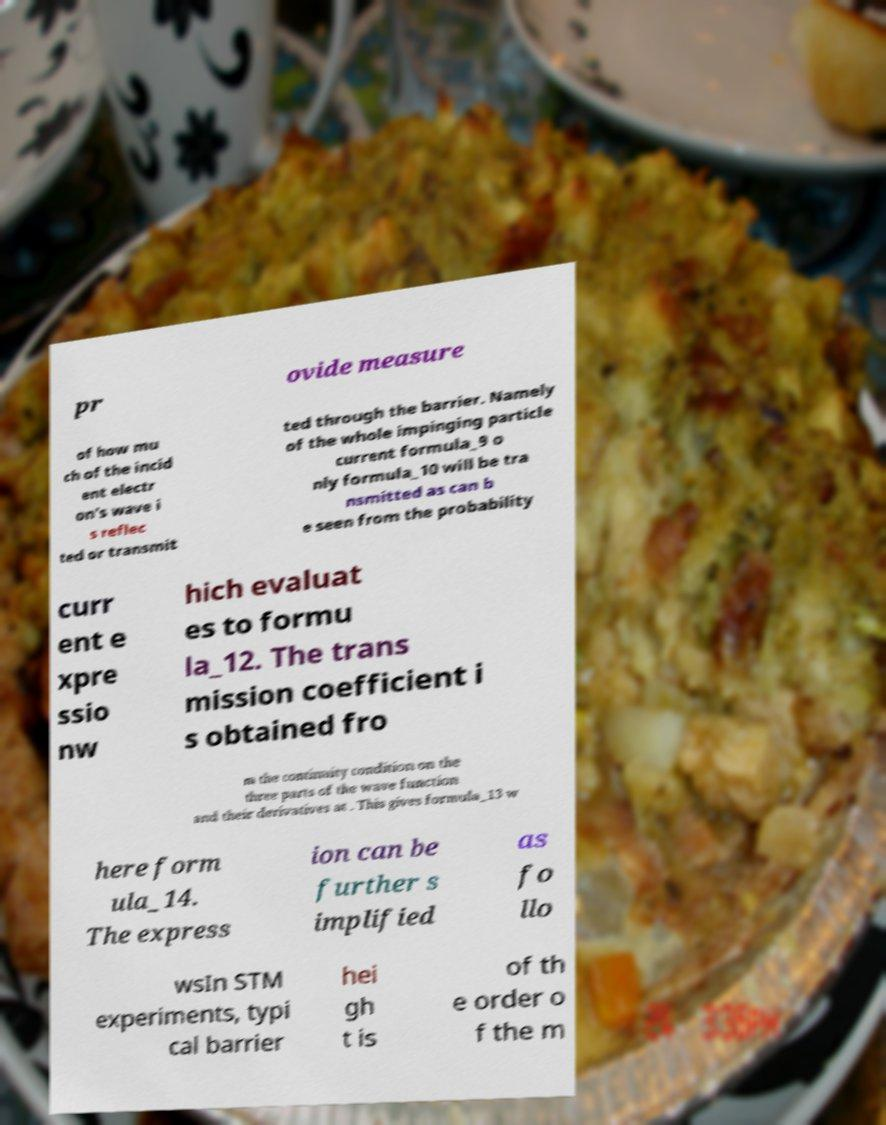Please read and relay the text visible in this image. What does it say? pr ovide measure of how mu ch of the incid ent electr on's wave i s reflec ted or transmit ted through the barrier. Namely of the whole impinging particle current formula_9 o nly formula_10 will be tra nsmitted as can b e seen from the probability curr ent e xpre ssio nw hich evaluat es to formu la_12. The trans mission coefficient i s obtained fro m the continuity condition on the three parts of the wave function and their derivatives at . This gives formula_13 w here form ula_14. The express ion can be further s implified as fo llo wsIn STM experiments, typi cal barrier hei gh t is of th e order o f the m 